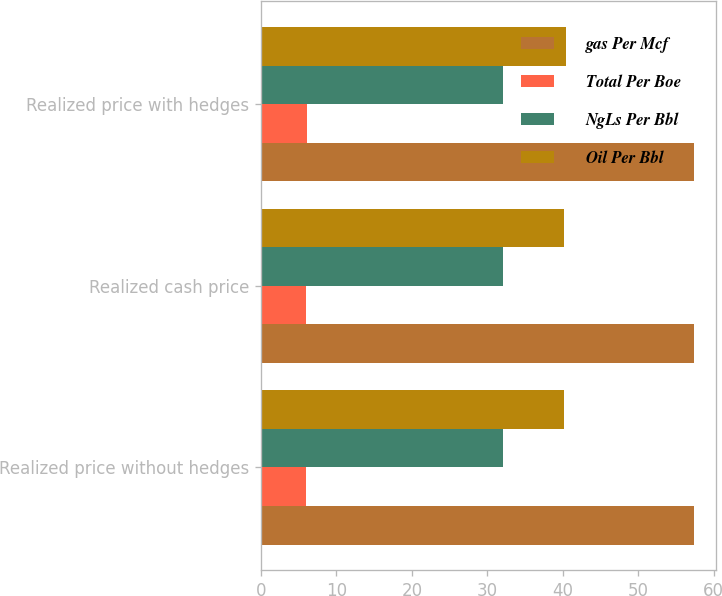Convert chart. <chart><loc_0><loc_0><loc_500><loc_500><stacked_bar_chart><ecel><fcel>Realized price without hedges<fcel>Realized cash price<fcel>Realized price with hedges<nl><fcel>gas Per Mcf<fcel>57.39<fcel>57.39<fcel>57.39<nl><fcel>Total Per Boe<fcel>6.03<fcel>6.03<fcel>6.08<nl><fcel>NgLs Per Bbl<fcel>32.1<fcel>32.1<fcel>32.1<nl><fcel>Oil Per Bbl<fcel>40.19<fcel>40.19<fcel>40.38<nl></chart> 